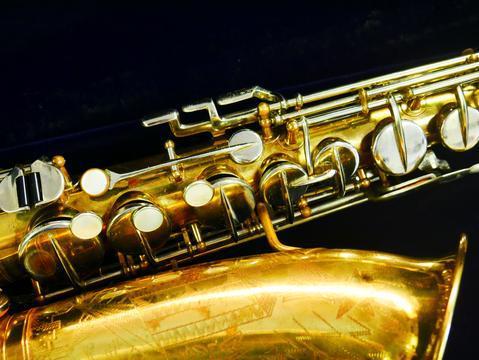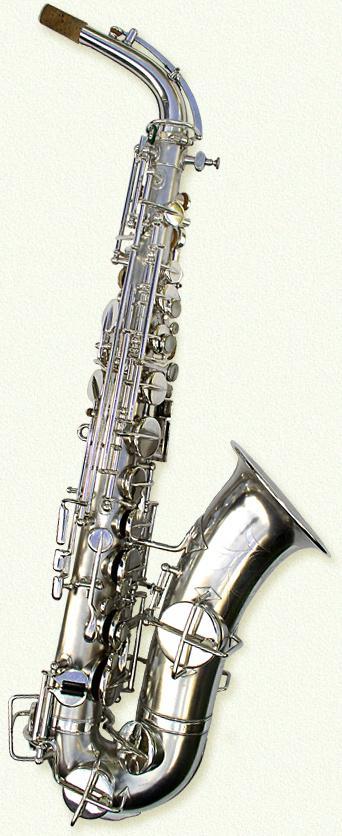The first image is the image on the left, the second image is the image on the right. Given the left and right images, does the statement "The mouthpiece of the instrument is disconnected and laying next to the instrument in the left image." hold true? Answer yes or no. No. The first image is the image on the left, the second image is the image on the right. Assess this claim about the two images: "One of the saxophones has etchings on it.". Correct or not? Answer yes or no. Yes. 